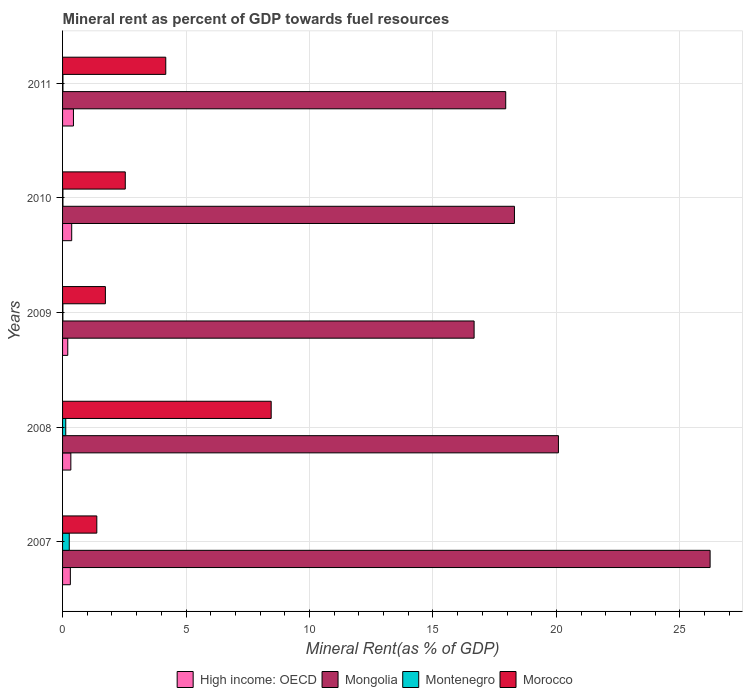Are the number of bars per tick equal to the number of legend labels?
Your answer should be very brief. Yes. Are the number of bars on each tick of the Y-axis equal?
Give a very brief answer. Yes. How many bars are there on the 5th tick from the top?
Your answer should be compact. 4. How many bars are there on the 4th tick from the bottom?
Your response must be concise. 4. What is the label of the 5th group of bars from the top?
Your answer should be compact. 2007. What is the mineral rent in High income: OECD in 2009?
Make the answer very short. 0.21. Across all years, what is the maximum mineral rent in Morocco?
Ensure brevity in your answer.  8.45. Across all years, what is the minimum mineral rent in Morocco?
Your answer should be very brief. 1.39. In which year was the mineral rent in High income: OECD maximum?
Your answer should be compact. 2011. In which year was the mineral rent in Morocco minimum?
Your answer should be very brief. 2007. What is the total mineral rent in High income: OECD in the graph?
Your answer should be compact. 1.67. What is the difference between the mineral rent in Mongolia in 2007 and that in 2008?
Offer a terse response. 6.14. What is the difference between the mineral rent in Montenegro in 2010 and the mineral rent in Morocco in 2008?
Your answer should be compact. -8.43. What is the average mineral rent in Morocco per year?
Your answer should be very brief. 3.66. In the year 2010, what is the difference between the mineral rent in High income: OECD and mineral rent in Montenegro?
Your response must be concise. 0.35. In how many years, is the mineral rent in Mongolia greater than 8 %?
Keep it short and to the point. 5. What is the ratio of the mineral rent in High income: OECD in 2008 to that in 2010?
Provide a short and direct response. 0.91. Is the difference between the mineral rent in High income: OECD in 2010 and 2011 greater than the difference between the mineral rent in Montenegro in 2010 and 2011?
Your answer should be compact. No. What is the difference between the highest and the second highest mineral rent in Mongolia?
Your answer should be compact. 6.14. What is the difference between the highest and the lowest mineral rent in Mongolia?
Give a very brief answer. 9.56. What does the 3rd bar from the top in 2009 represents?
Ensure brevity in your answer.  Mongolia. What does the 2nd bar from the bottom in 2008 represents?
Provide a short and direct response. Mongolia. Are all the bars in the graph horizontal?
Provide a short and direct response. Yes. How many years are there in the graph?
Ensure brevity in your answer.  5. What is the difference between two consecutive major ticks on the X-axis?
Offer a very short reply. 5. Does the graph contain any zero values?
Give a very brief answer. No. Does the graph contain grids?
Your response must be concise. Yes. What is the title of the graph?
Your answer should be compact. Mineral rent as percent of GDP towards fuel resources. Does "Burundi" appear as one of the legend labels in the graph?
Your answer should be compact. No. What is the label or title of the X-axis?
Make the answer very short. Mineral Rent(as % of GDP). What is the label or title of the Y-axis?
Provide a succinct answer. Years. What is the Mineral Rent(as % of GDP) in High income: OECD in 2007?
Give a very brief answer. 0.32. What is the Mineral Rent(as % of GDP) of Mongolia in 2007?
Your answer should be very brief. 26.23. What is the Mineral Rent(as % of GDP) in Montenegro in 2007?
Ensure brevity in your answer.  0.27. What is the Mineral Rent(as % of GDP) of Morocco in 2007?
Give a very brief answer. 1.39. What is the Mineral Rent(as % of GDP) of High income: OECD in 2008?
Provide a succinct answer. 0.34. What is the Mineral Rent(as % of GDP) of Mongolia in 2008?
Your response must be concise. 20.08. What is the Mineral Rent(as % of GDP) of Montenegro in 2008?
Your answer should be compact. 0.13. What is the Mineral Rent(as % of GDP) of Morocco in 2008?
Make the answer very short. 8.45. What is the Mineral Rent(as % of GDP) in High income: OECD in 2009?
Offer a very short reply. 0.21. What is the Mineral Rent(as % of GDP) in Mongolia in 2009?
Your answer should be very brief. 16.67. What is the Mineral Rent(as % of GDP) in Montenegro in 2009?
Your response must be concise. 0.01. What is the Mineral Rent(as % of GDP) of Morocco in 2009?
Ensure brevity in your answer.  1.73. What is the Mineral Rent(as % of GDP) in High income: OECD in 2010?
Give a very brief answer. 0.37. What is the Mineral Rent(as % of GDP) of Mongolia in 2010?
Offer a terse response. 18.3. What is the Mineral Rent(as % of GDP) of Montenegro in 2010?
Offer a terse response. 0.02. What is the Mineral Rent(as % of GDP) of Morocco in 2010?
Your response must be concise. 2.54. What is the Mineral Rent(as % of GDP) of High income: OECD in 2011?
Offer a terse response. 0.44. What is the Mineral Rent(as % of GDP) of Mongolia in 2011?
Offer a very short reply. 17.95. What is the Mineral Rent(as % of GDP) of Montenegro in 2011?
Your answer should be compact. 0.02. What is the Mineral Rent(as % of GDP) in Morocco in 2011?
Ensure brevity in your answer.  4.18. Across all years, what is the maximum Mineral Rent(as % of GDP) in High income: OECD?
Make the answer very short. 0.44. Across all years, what is the maximum Mineral Rent(as % of GDP) of Mongolia?
Your response must be concise. 26.23. Across all years, what is the maximum Mineral Rent(as % of GDP) in Montenegro?
Your answer should be very brief. 0.27. Across all years, what is the maximum Mineral Rent(as % of GDP) in Morocco?
Your response must be concise. 8.45. Across all years, what is the minimum Mineral Rent(as % of GDP) in High income: OECD?
Keep it short and to the point. 0.21. Across all years, what is the minimum Mineral Rent(as % of GDP) in Mongolia?
Make the answer very short. 16.67. Across all years, what is the minimum Mineral Rent(as % of GDP) in Montenegro?
Make the answer very short. 0.01. Across all years, what is the minimum Mineral Rent(as % of GDP) of Morocco?
Your answer should be very brief. 1.39. What is the total Mineral Rent(as % of GDP) of High income: OECD in the graph?
Your answer should be compact. 1.67. What is the total Mineral Rent(as % of GDP) of Mongolia in the graph?
Give a very brief answer. 99.23. What is the total Mineral Rent(as % of GDP) of Montenegro in the graph?
Provide a short and direct response. 0.44. What is the total Mineral Rent(as % of GDP) of Morocco in the graph?
Offer a very short reply. 18.29. What is the difference between the Mineral Rent(as % of GDP) of High income: OECD in 2007 and that in 2008?
Your response must be concise. -0.02. What is the difference between the Mineral Rent(as % of GDP) of Mongolia in 2007 and that in 2008?
Your answer should be very brief. 6.14. What is the difference between the Mineral Rent(as % of GDP) in Montenegro in 2007 and that in 2008?
Provide a succinct answer. 0.14. What is the difference between the Mineral Rent(as % of GDP) in Morocco in 2007 and that in 2008?
Provide a short and direct response. -7.06. What is the difference between the Mineral Rent(as % of GDP) of High income: OECD in 2007 and that in 2009?
Your response must be concise. 0.11. What is the difference between the Mineral Rent(as % of GDP) in Mongolia in 2007 and that in 2009?
Give a very brief answer. 9.56. What is the difference between the Mineral Rent(as % of GDP) of Montenegro in 2007 and that in 2009?
Ensure brevity in your answer.  0.26. What is the difference between the Mineral Rent(as % of GDP) of Morocco in 2007 and that in 2009?
Make the answer very short. -0.35. What is the difference between the Mineral Rent(as % of GDP) in High income: OECD in 2007 and that in 2010?
Provide a succinct answer. -0.05. What is the difference between the Mineral Rent(as % of GDP) in Mongolia in 2007 and that in 2010?
Give a very brief answer. 7.92. What is the difference between the Mineral Rent(as % of GDP) of Montenegro in 2007 and that in 2010?
Offer a very short reply. 0.26. What is the difference between the Mineral Rent(as % of GDP) in Morocco in 2007 and that in 2010?
Your response must be concise. -1.15. What is the difference between the Mineral Rent(as % of GDP) in High income: OECD in 2007 and that in 2011?
Give a very brief answer. -0.13. What is the difference between the Mineral Rent(as % of GDP) in Mongolia in 2007 and that in 2011?
Your response must be concise. 8.28. What is the difference between the Mineral Rent(as % of GDP) in Montenegro in 2007 and that in 2011?
Give a very brief answer. 0.26. What is the difference between the Mineral Rent(as % of GDP) in Morocco in 2007 and that in 2011?
Offer a very short reply. -2.79. What is the difference between the Mineral Rent(as % of GDP) of High income: OECD in 2008 and that in 2009?
Your response must be concise. 0.12. What is the difference between the Mineral Rent(as % of GDP) in Mongolia in 2008 and that in 2009?
Your response must be concise. 3.42. What is the difference between the Mineral Rent(as % of GDP) of Montenegro in 2008 and that in 2009?
Give a very brief answer. 0.12. What is the difference between the Mineral Rent(as % of GDP) of Morocco in 2008 and that in 2009?
Ensure brevity in your answer.  6.71. What is the difference between the Mineral Rent(as % of GDP) of High income: OECD in 2008 and that in 2010?
Give a very brief answer. -0.03. What is the difference between the Mineral Rent(as % of GDP) of Mongolia in 2008 and that in 2010?
Make the answer very short. 1.78. What is the difference between the Mineral Rent(as % of GDP) in Montenegro in 2008 and that in 2010?
Give a very brief answer. 0.11. What is the difference between the Mineral Rent(as % of GDP) of Morocco in 2008 and that in 2010?
Make the answer very short. 5.91. What is the difference between the Mineral Rent(as % of GDP) in High income: OECD in 2008 and that in 2011?
Provide a short and direct response. -0.11. What is the difference between the Mineral Rent(as % of GDP) in Mongolia in 2008 and that in 2011?
Make the answer very short. 2.13. What is the difference between the Mineral Rent(as % of GDP) in Montenegro in 2008 and that in 2011?
Your answer should be compact. 0.11. What is the difference between the Mineral Rent(as % of GDP) in Morocco in 2008 and that in 2011?
Your response must be concise. 4.27. What is the difference between the Mineral Rent(as % of GDP) in High income: OECD in 2009 and that in 2010?
Keep it short and to the point. -0.16. What is the difference between the Mineral Rent(as % of GDP) of Mongolia in 2009 and that in 2010?
Your answer should be very brief. -1.63. What is the difference between the Mineral Rent(as % of GDP) of Montenegro in 2009 and that in 2010?
Your answer should be very brief. -0. What is the difference between the Mineral Rent(as % of GDP) in Morocco in 2009 and that in 2010?
Offer a very short reply. -0.81. What is the difference between the Mineral Rent(as % of GDP) in High income: OECD in 2009 and that in 2011?
Provide a short and direct response. -0.23. What is the difference between the Mineral Rent(as % of GDP) of Mongolia in 2009 and that in 2011?
Make the answer very short. -1.28. What is the difference between the Mineral Rent(as % of GDP) of Montenegro in 2009 and that in 2011?
Provide a short and direct response. -0. What is the difference between the Mineral Rent(as % of GDP) of Morocco in 2009 and that in 2011?
Your response must be concise. -2.45. What is the difference between the Mineral Rent(as % of GDP) in High income: OECD in 2010 and that in 2011?
Keep it short and to the point. -0.07. What is the difference between the Mineral Rent(as % of GDP) in Mongolia in 2010 and that in 2011?
Give a very brief answer. 0.35. What is the difference between the Mineral Rent(as % of GDP) in Montenegro in 2010 and that in 2011?
Provide a short and direct response. -0. What is the difference between the Mineral Rent(as % of GDP) in Morocco in 2010 and that in 2011?
Provide a short and direct response. -1.64. What is the difference between the Mineral Rent(as % of GDP) in High income: OECD in 2007 and the Mineral Rent(as % of GDP) in Mongolia in 2008?
Your answer should be very brief. -19.77. What is the difference between the Mineral Rent(as % of GDP) of High income: OECD in 2007 and the Mineral Rent(as % of GDP) of Montenegro in 2008?
Your response must be concise. 0.19. What is the difference between the Mineral Rent(as % of GDP) of High income: OECD in 2007 and the Mineral Rent(as % of GDP) of Morocco in 2008?
Offer a very short reply. -8.13. What is the difference between the Mineral Rent(as % of GDP) of Mongolia in 2007 and the Mineral Rent(as % of GDP) of Montenegro in 2008?
Give a very brief answer. 26.1. What is the difference between the Mineral Rent(as % of GDP) of Mongolia in 2007 and the Mineral Rent(as % of GDP) of Morocco in 2008?
Your answer should be compact. 17.78. What is the difference between the Mineral Rent(as % of GDP) of Montenegro in 2007 and the Mineral Rent(as % of GDP) of Morocco in 2008?
Your response must be concise. -8.18. What is the difference between the Mineral Rent(as % of GDP) of High income: OECD in 2007 and the Mineral Rent(as % of GDP) of Mongolia in 2009?
Your answer should be very brief. -16.35. What is the difference between the Mineral Rent(as % of GDP) of High income: OECD in 2007 and the Mineral Rent(as % of GDP) of Montenegro in 2009?
Your response must be concise. 0.3. What is the difference between the Mineral Rent(as % of GDP) of High income: OECD in 2007 and the Mineral Rent(as % of GDP) of Morocco in 2009?
Keep it short and to the point. -1.42. What is the difference between the Mineral Rent(as % of GDP) of Mongolia in 2007 and the Mineral Rent(as % of GDP) of Montenegro in 2009?
Offer a very short reply. 26.21. What is the difference between the Mineral Rent(as % of GDP) in Mongolia in 2007 and the Mineral Rent(as % of GDP) in Morocco in 2009?
Keep it short and to the point. 24.49. What is the difference between the Mineral Rent(as % of GDP) in Montenegro in 2007 and the Mineral Rent(as % of GDP) in Morocco in 2009?
Your answer should be very brief. -1.46. What is the difference between the Mineral Rent(as % of GDP) of High income: OECD in 2007 and the Mineral Rent(as % of GDP) of Mongolia in 2010?
Your answer should be compact. -17.99. What is the difference between the Mineral Rent(as % of GDP) in High income: OECD in 2007 and the Mineral Rent(as % of GDP) in Montenegro in 2010?
Offer a very short reply. 0.3. What is the difference between the Mineral Rent(as % of GDP) of High income: OECD in 2007 and the Mineral Rent(as % of GDP) of Morocco in 2010?
Offer a terse response. -2.22. What is the difference between the Mineral Rent(as % of GDP) of Mongolia in 2007 and the Mineral Rent(as % of GDP) of Montenegro in 2010?
Give a very brief answer. 26.21. What is the difference between the Mineral Rent(as % of GDP) in Mongolia in 2007 and the Mineral Rent(as % of GDP) in Morocco in 2010?
Give a very brief answer. 23.69. What is the difference between the Mineral Rent(as % of GDP) in Montenegro in 2007 and the Mineral Rent(as % of GDP) in Morocco in 2010?
Make the answer very short. -2.27. What is the difference between the Mineral Rent(as % of GDP) of High income: OECD in 2007 and the Mineral Rent(as % of GDP) of Mongolia in 2011?
Give a very brief answer. -17.63. What is the difference between the Mineral Rent(as % of GDP) of High income: OECD in 2007 and the Mineral Rent(as % of GDP) of Morocco in 2011?
Keep it short and to the point. -3.86. What is the difference between the Mineral Rent(as % of GDP) of Mongolia in 2007 and the Mineral Rent(as % of GDP) of Montenegro in 2011?
Ensure brevity in your answer.  26.21. What is the difference between the Mineral Rent(as % of GDP) in Mongolia in 2007 and the Mineral Rent(as % of GDP) in Morocco in 2011?
Provide a short and direct response. 22.05. What is the difference between the Mineral Rent(as % of GDP) of Montenegro in 2007 and the Mineral Rent(as % of GDP) of Morocco in 2011?
Your response must be concise. -3.91. What is the difference between the Mineral Rent(as % of GDP) in High income: OECD in 2008 and the Mineral Rent(as % of GDP) in Mongolia in 2009?
Your response must be concise. -16.33. What is the difference between the Mineral Rent(as % of GDP) of High income: OECD in 2008 and the Mineral Rent(as % of GDP) of Montenegro in 2009?
Offer a very short reply. 0.32. What is the difference between the Mineral Rent(as % of GDP) in High income: OECD in 2008 and the Mineral Rent(as % of GDP) in Morocco in 2009?
Ensure brevity in your answer.  -1.4. What is the difference between the Mineral Rent(as % of GDP) of Mongolia in 2008 and the Mineral Rent(as % of GDP) of Montenegro in 2009?
Give a very brief answer. 20.07. What is the difference between the Mineral Rent(as % of GDP) of Mongolia in 2008 and the Mineral Rent(as % of GDP) of Morocco in 2009?
Give a very brief answer. 18.35. What is the difference between the Mineral Rent(as % of GDP) in Montenegro in 2008 and the Mineral Rent(as % of GDP) in Morocco in 2009?
Provide a short and direct response. -1.61. What is the difference between the Mineral Rent(as % of GDP) in High income: OECD in 2008 and the Mineral Rent(as % of GDP) in Mongolia in 2010?
Provide a succinct answer. -17.97. What is the difference between the Mineral Rent(as % of GDP) of High income: OECD in 2008 and the Mineral Rent(as % of GDP) of Montenegro in 2010?
Give a very brief answer. 0.32. What is the difference between the Mineral Rent(as % of GDP) in High income: OECD in 2008 and the Mineral Rent(as % of GDP) in Morocco in 2010?
Your answer should be compact. -2.2. What is the difference between the Mineral Rent(as % of GDP) of Mongolia in 2008 and the Mineral Rent(as % of GDP) of Montenegro in 2010?
Keep it short and to the point. 20.07. What is the difference between the Mineral Rent(as % of GDP) of Mongolia in 2008 and the Mineral Rent(as % of GDP) of Morocco in 2010?
Make the answer very short. 17.54. What is the difference between the Mineral Rent(as % of GDP) in Montenegro in 2008 and the Mineral Rent(as % of GDP) in Morocco in 2010?
Provide a succinct answer. -2.41. What is the difference between the Mineral Rent(as % of GDP) of High income: OECD in 2008 and the Mineral Rent(as % of GDP) of Mongolia in 2011?
Ensure brevity in your answer.  -17.61. What is the difference between the Mineral Rent(as % of GDP) of High income: OECD in 2008 and the Mineral Rent(as % of GDP) of Montenegro in 2011?
Offer a very short reply. 0.32. What is the difference between the Mineral Rent(as % of GDP) of High income: OECD in 2008 and the Mineral Rent(as % of GDP) of Morocco in 2011?
Provide a short and direct response. -3.84. What is the difference between the Mineral Rent(as % of GDP) in Mongolia in 2008 and the Mineral Rent(as % of GDP) in Montenegro in 2011?
Make the answer very short. 20.07. What is the difference between the Mineral Rent(as % of GDP) of Mongolia in 2008 and the Mineral Rent(as % of GDP) of Morocco in 2011?
Keep it short and to the point. 15.9. What is the difference between the Mineral Rent(as % of GDP) of Montenegro in 2008 and the Mineral Rent(as % of GDP) of Morocco in 2011?
Give a very brief answer. -4.05. What is the difference between the Mineral Rent(as % of GDP) in High income: OECD in 2009 and the Mineral Rent(as % of GDP) in Mongolia in 2010?
Keep it short and to the point. -18.09. What is the difference between the Mineral Rent(as % of GDP) of High income: OECD in 2009 and the Mineral Rent(as % of GDP) of Montenegro in 2010?
Ensure brevity in your answer.  0.2. What is the difference between the Mineral Rent(as % of GDP) of High income: OECD in 2009 and the Mineral Rent(as % of GDP) of Morocco in 2010?
Your answer should be compact. -2.33. What is the difference between the Mineral Rent(as % of GDP) of Mongolia in 2009 and the Mineral Rent(as % of GDP) of Montenegro in 2010?
Your answer should be very brief. 16.65. What is the difference between the Mineral Rent(as % of GDP) of Mongolia in 2009 and the Mineral Rent(as % of GDP) of Morocco in 2010?
Provide a succinct answer. 14.13. What is the difference between the Mineral Rent(as % of GDP) in Montenegro in 2009 and the Mineral Rent(as % of GDP) in Morocco in 2010?
Your answer should be very brief. -2.53. What is the difference between the Mineral Rent(as % of GDP) in High income: OECD in 2009 and the Mineral Rent(as % of GDP) in Mongolia in 2011?
Your response must be concise. -17.74. What is the difference between the Mineral Rent(as % of GDP) in High income: OECD in 2009 and the Mineral Rent(as % of GDP) in Montenegro in 2011?
Your answer should be compact. 0.19. What is the difference between the Mineral Rent(as % of GDP) of High income: OECD in 2009 and the Mineral Rent(as % of GDP) of Morocco in 2011?
Provide a short and direct response. -3.97. What is the difference between the Mineral Rent(as % of GDP) in Mongolia in 2009 and the Mineral Rent(as % of GDP) in Montenegro in 2011?
Provide a short and direct response. 16.65. What is the difference between the Mineral Rent(as % of GDP) of Mongolia in 2009 and the Mineral Rent(as % of GDP) of Morocco in 2011?
Offer a terse response. 12.49. What is the difference between the Mineral Rent(as % of GDP) in Montenegro in 2009 and the Mineral Rent(as % of GDP) in Morocco in 2011?
Your response must be concise. -4.17. What is the difference between the Mineral Rent(as % of GDP) of High income: OECD in 2010 and the Mineral Rent(as % of GDP) of Mongolia in 2011?
Your response must be concise. -17.58. What is the difference between the Mineral Rent(as % of GDP) of High income: OECD in 2010 and the Mineral Rent(as % of GDP) of Montenegro in 2011?
Your answer should be compact. 0.35. What is the difference between the Mineral Rent(as % of GDP) of High income: OECD in 2010 and the Mineral Rent(as % of GDP) of Morocco in 2011?
Keep it short and to the point. -3.81. What is the difference between the Mineral Rent(as % of GDP) in Mongolia in 2010 and the Mineral Rent(as % of GDP) in Montenegro in 2011?
Your answer should be very brief. 18.29. What is the difference between the Mineral Rent(as % of GDP) of Mongolia in 2010 and the Mineral Rent(as % of GDP) of Morocco in 2011?
Provide a succinct answer. 14.12. What is the difference between the Mineral Rent(as % of GDP) in Montenegro in 2010 and the Mineral Rent(as % of GDP) in Morocco in 2011?
Ensure brevity in your answer.  -4.16. What is the average Mineral Rent(as % of GDP) of High income: OECD per year?
Your answer should be compact. 0.33. What is the average Mineral Rent(as % of GDP) of Mongolia per year?
Make the answer very short. 19.84. What is the average Mineral Rent(as % of GDP) of Montenegro per year?
Offer a very short reply. 0.09. What is the average Mineral Rent(as % of GDP) of Morocco per year?
Give a very brief answer. 3.66. In the year 2007, what is the difference between the Mineral Rent(as % of GDP) in High income: OECD and Mineral Rent(as % of GDP) in Mongolia?
Offer a very short reply. -25.91. In the year 2007, what is the difference between the Mineral Rent(as % of GDP) of High income: OECD and Mineral Rent(as % of GDP) of Montenegro?
Offer a terse response. 0.04. In the year 2007, what is the difference between the Mineral Rent(as % of GDP) in High income: OECD and Mineral Rent(as % of GDP) in Morocco?
Your answer should be very brief. -1.07. In the year 2007, what is the difference between the Mineral Rent(as % of GDP) of Mongolia and Mineral Rent(as % of GDP) of Montenegro?
Provide a short and direct response. 25.95. In the year 2007, what is the difference between the Mineral Rent(as % of GDP) of Mongolia and Mineral Rent(as % of GDP) of Morocco?
Ensure brevity in your answer.  24.84. In the year 2007, what is the difference between the Mineral Rent(as % of GDP) of Montenegro and Mineral Rent(as % of GDP) of Morocco?
Make the answer very short. -1.12. In the year 2008, what is the difference between the Mineral Rent(as % of GDP) of High income: OECD and Mineral Rent(as % of GDP) of Mongolia?
Provide a short and direct response. -19.75. In the year 2008, what is the difference between the Mineral Rent(as % of GDP) of High income: OECD and Mineral Rent(as % of GDP) of Montenegro?
Make the answer very short. 0.21. In the year 2008, what is the difference between the Mineral Rent(as % of GDP) in High income: OECD and Mineral Rent(as % of GDP) in Morocco?
Offer a terse response. -8.11. In the year 2008, what is the difference between the Mineral Rent(as % of GDP) in Mongolia and Mineral Rent(as % of GDP) in Montenegro?
Make the answer very short. 19.95. In the year 2008, what is the difference between the Mineral Rent(as % of GDP) in Mongolia and Mineral Rent(as % of GDP) in Morocco?
Provide a short and direct response. 11.63. In the year 2008, what is the difference between the Mineral Rent(as % of GDP) of Montenegro and Mineral Rent(as % of GDP) of Morocco?
Give a very brief answer. -8.32. In the year 2009, what is the difference between the Mineral Rent(as % of GDP) of High income: OECD and Mineral Rent(as % of GDP) of Mongolia?
Offer a very short reply. -16.46. In the year 2009, what is the difference between the Mineral Rent(as % of GDP) of High income: OECD and Mineral Rent(as % of GDP) of Montenegro?
Your answer should be very brief. 0.2. In the year 2009, what is the difference between the Mineral Rent(as % of GDP) in High income: OECD and Mineral Rent(as % of GDP) in Morocco?
Make the answer very short. -1.52. In the year 2009, what is the difference between the Mineral Rent(as % of GDP) of Mongolia and Mineral Rent(as % of GDP) of Montenegro?
Keep it short and to the point. 16.65. In the year 2009, what is the difference between the Mineral Rent(as % of GDP) in Mongolia and Mineral Rent(as % of GDP) in Morocco?
Ensure brevity in your answer.  14.93. In the year 2009, what is the difference between the Mineral Rent(as % of GDP) of Montenegro and Mineral Rent(as % of GDP) of Morocco?
Offer a terse response. -1.72. In the year 2010, what is the difference between the Mineral Rent(as % of GDP) of High income: OECD and Mineral Rent(as % of GDP) of Mongolia?
Your answer should be very brief. -17.93. In the year 2010, what is the difference between the Mineral Rent(as % of GDP) of High income: OECD and Mineral Rent(as % of GDP) of Montenegro?
Keep it short and to the point. 0.35. In the year 2010, what is the difference between the Mineral Rent(as % of GDP) in High income: OECD and Mineral Rent(as % of GDP) in Morocco?
Provide a succinct answer. -2.17. In the year 2010, what is the difference between the Mineral Rent(as % of GDP) of Mongolia and Mineral Rent(as % of GDP) of Montenegro?
Ensure brevity in your answer.  18.29. In the year 2010, what is the difference between the Mineral Rent(as % of GDP) of Mongolia and Mineral Rent(as % of GDP) of Morocco?
Offer a very short reply. 15.76. In the year 2010, what is the difference between the Mineral Rent(as % of GDP) in Montenegro and Mineral Rent(as % of GDP) in Morocco?
Make the answer very short. -2.52. In the year 2011, what is the difference between the Mineral Rent(as % of GDP) in High income: OECD and Mineral Rent(as % of GDP) in Mongolia?
Provide a short and direct response. -17.51. In the year 2011, what is the difference between the Mineral Rent(as % of GDP) in High income: OECD and Mineral Rent(as % of GDP) in Montenegro?
Give a very brief answer. 0.43. In the year 2011, what is the difference between the Mineral Rent(as % of GDP) of High income: OECD and Mineral Rent(as % of GDP) of Morocco?
Your answer should be compact. -3.74. In the year 2011, what is the difference between the Mineral Rent(as % of GDP) in Mongolia and Mineral Rent(as % of GDP) in Montenegro?
Ensure brevity in your answer.  17.93. In the year 2011, what is the difference between the Mineral Rent(as % of GDP) of Mongolia and Mineral Rent(as % of GDP) of Morocco?
Make the answer very short. 13.77. In the year 2011, what is the difference between the Mineral Rent(as % of GDP) of Montenegro and Mineral Rent(as % of GDP) of Morocco?
Your response must be concise. -4.16. What is the ratio of the Mineral Rent(as % of GDP) of High income: OECD in 2007 to that in 2008?
Provide a short and direct response. 0.94. What is the ratio of the Mineral Rent(as % of GDP) in Mongolia in 2007 to that in 2008?
Your response must be concise. 1.31. What is the ratio of the Mineral Rent(as % of GDP) in Montenegro in 2007 to that in 2008?
Provide a succinct answer. 2.1. What is the ratio of the Mineral Rent(as % of GDP) of Morocco in 2007 to that in 2008?
Make the answer very short. 0.16. What is the ratio of the Mineral Rent(as % of GDP) in High income: OECD in 2007 to that in 2009?
Your answer should be compact. 1.5. What is the ratio of the Mineral Rent(as % of GDP) of Mongolia in 2007 to that in 2009?
Keep it short and to the point. 1.57. What is the ratio of the Mineral Rent(as % of GDP) of Montenegro in 2007 to that in 2009?
Your answer should be compact. 20.89. What is the ratio of the Mineral Rent(as % of GDP) of Morocco in 2007 to that in 2009?
Keep it short and to the point. 0.8. What is the ratio of the Mineral Rent(as % of GDP) of High income: OECD in 2007 to that in 2010?
Your answer should be very brief. 0.85. What is the ratio of the Mineral Rent(as % of GDP) of Mongolia in 2007 to that in 2010?
Keep it short and to the point. 1.43. What is the ratio of the Mineral Rent(as % of GDP) of Montenegro in 2007 to that in 2010?
Make the answer very short. 17.95. What is the ratio of the Mineral Rent(as % of GDP) of Morocco in 2007 to that in 2010?
Your answer should be compact. 0.55. What is the ratio of the Mineral Rent(as % of GDP) of High income: OECD in 2007 to that in 2011?
Ensure brevity in your answer.  0.72. What is the ratio of the Mineral Rent(as % of GDP) of Mongolia in 2007 to that in 2011?
Offer a terse response. 1.46. What is the ratio of the Mineral Rent(as % of GDP) in Montenegro in 2007 to that in 2011?
Offer a very short reply. 17.45. What is the ratio of the Mineral Rent(as % of GDP) in Morocco in 2007 to that in 2011?
Your answer should be compact. 0.33. What is the ratio of the Mineral Rent(as % of GDP) of High income: OECD in 2008 to that in 2009?
Make the answer very short. 1.59. What is the ratio of the Mineral Rent(as % of GDP) in Mongolia in 2008 to that in 2009?
Provide a short and direct response. 1.2. What is the ratio of the Mineral Rent(as % of GDP) of Montenegro in 2008 to that in 2009?
Offer a terse response. 9.93. What is the ratio of the Mineral Rent(as % of GDP) of Morocco in 2008 to that in 2009?
Offer a terse response. 4.87. What is the ratio of the Mineral Rent(as % of GDP) of High income: OECD in 2008 to that in 2010?
Ensure brevity in your answer.  0.91. What is the ratio of the Mineral Rent(as % of GDP) in Mongolia in 2008 to that in 2010?
Your response must be concise. 1.1. What is the ratio of the Mineral Rent(as % of GDP) in Montenegro in 2008 to that in 2010?
Ensure brevity in your answer.  8.53. What is the ratio of the Mineral Rent(as % of GDP) in Morocco in 2008 to that in 2010?
Ensure brevity in your answer.  3.33. What is the ratio of the Mineral Rent(as % of GDP) in High income: OECD in 2008 to that in 2011?
Make the answer very short. 0.76. What is the ratio of the Mineral Rent(as % of GDP) in Mongolia in 2008 to that in 2011?
Provide a succinct answer. 1.12. What is the ratio of the Mineral Rent(as % of GDP) of Montenegro in 2008 to that in 2011?
Give a very brief answer. 8.3. What is the ratio of the Mineral Rent(as % of GDP) in Morocco in 2008 to that in 2011?
Provide a short and direct response. 2.02. What is the ratio of the Mineral Rent(as % of GDP) in High income: OECD in 2009 to that in 2010?
Give a very brief answer. 0.57. What is the ratio of the Mineral Rent(as % of GDP) of Mongolia in 2009 to that in 2010?
Offer a terse response. 0.91. What is the ratio of the Mineral Rent(as % of GDP) in Montenegro in 2009 to that in 2010?
Your answer should be compact. 0.86. What is the ratio of the Mineral Rent(as % of GDP) in Morocco in 2009 to that in 2010?
Your answer should be compact. 0.68. What is the ratio of the Mineral Rent(as % of GDP) of High income: OECD in 2009 to that in 2011?
Ensure brevity in your answer.  0.48. What is the ratio of the Mineral Rent(as % of GDP) in Mongolia in 2009 to that in 2011?
Offer a terse response. 0.93. What is the ratio of the Mineral Rent(as % of GDP) of Montenegro in 2009 to that in 2011?
Your response must be concise. 0.84. What is the ratio of the Mineral Rent(as % of GDP) in Morocco in 2009 to that in 2011?
Provide a short and direct response. 0.41. What is the ratio of the Mineral Rent(as % of GDP) of High income: OECD in 2010 to that in 2011?
Provide a short and direct response. 0.84. What is the ratio of the Mineral Rent(as % of GDP) in Mongolia in 2010 to that in 2011?
Your answer should be compact. 1.02. What is the ratio of the Mineral Rent(as % of GDP) in Montenegro in 2010 to that in 2011?
Your answer should be compact. 0.97. What is the ratio of the Mineral Rent(as % of GDP) of Morocco in 2010 to that in 2011?
Your answer should be very brief. 0.61. What is the difference between the highest and the second highest Mineral Rent(as % of GDP) of High income: OECD?
Your answer should be compact. 0.07. What is the difference between the highest and the second highest Mineral Rent(as % of GDP) in Mongolia?
Provide a short and direct response. 6.14. What is the difference between the highest and the second highest Mineral Rent(as % of GDP) of Montenegro?
Provide a short and direct response. 0.14. What is the difference between the highest and the second highest Mineral Rent(as % of GDP) in Morocco?
Offer a very short reply. 4.27. What is the difference between the highest and the lowest Mineral Rent(as % of GDP) in High income: OECD?
Your answer should be very brief. 0.23. What is the difference between the highest and the lowest Mineral Rent(as % of GDP) of Mongolia?
Provide a succinct answer. 9.56. What is the difference between the highest and the lowest Mineral Rent(as % of GDP) in Montenegro?
Provide a short and direct response. 0.26. What is the difference between the highest and the lowest Mineral Rent(as % of GDP) in Morocco?
Your answer should be compact. 7.06. 